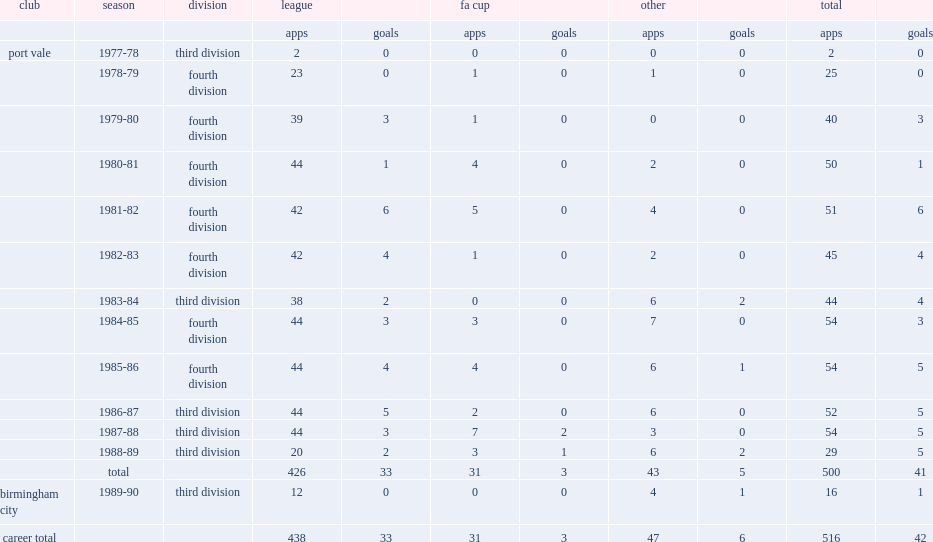In the 1985-86 season, which division did sproson of port vale play in? Fourth division. 